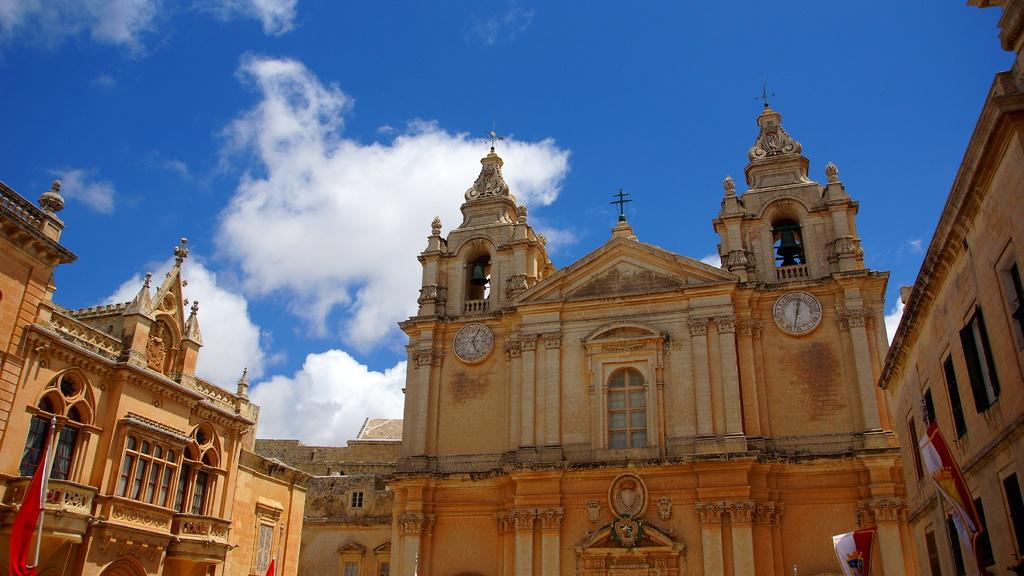What type of structures can be seen in the image? There are buildings in the image. What decorative elements are present on the buildings? There are flags and clocks on the buildings. What other objects can be seen in the image? There are bells in the image. What can be seen in the background of the image? The sky is visible in the background of the image. What is the condition of the sky in the image? Clouds are present in the sky. What type of pancake is being served at the holiday event in the image? There is no pancake or holiday event present in the image. How many houses are visible in the image? There are no houses mentioned in the facts provided; only buildings are mentioned. 